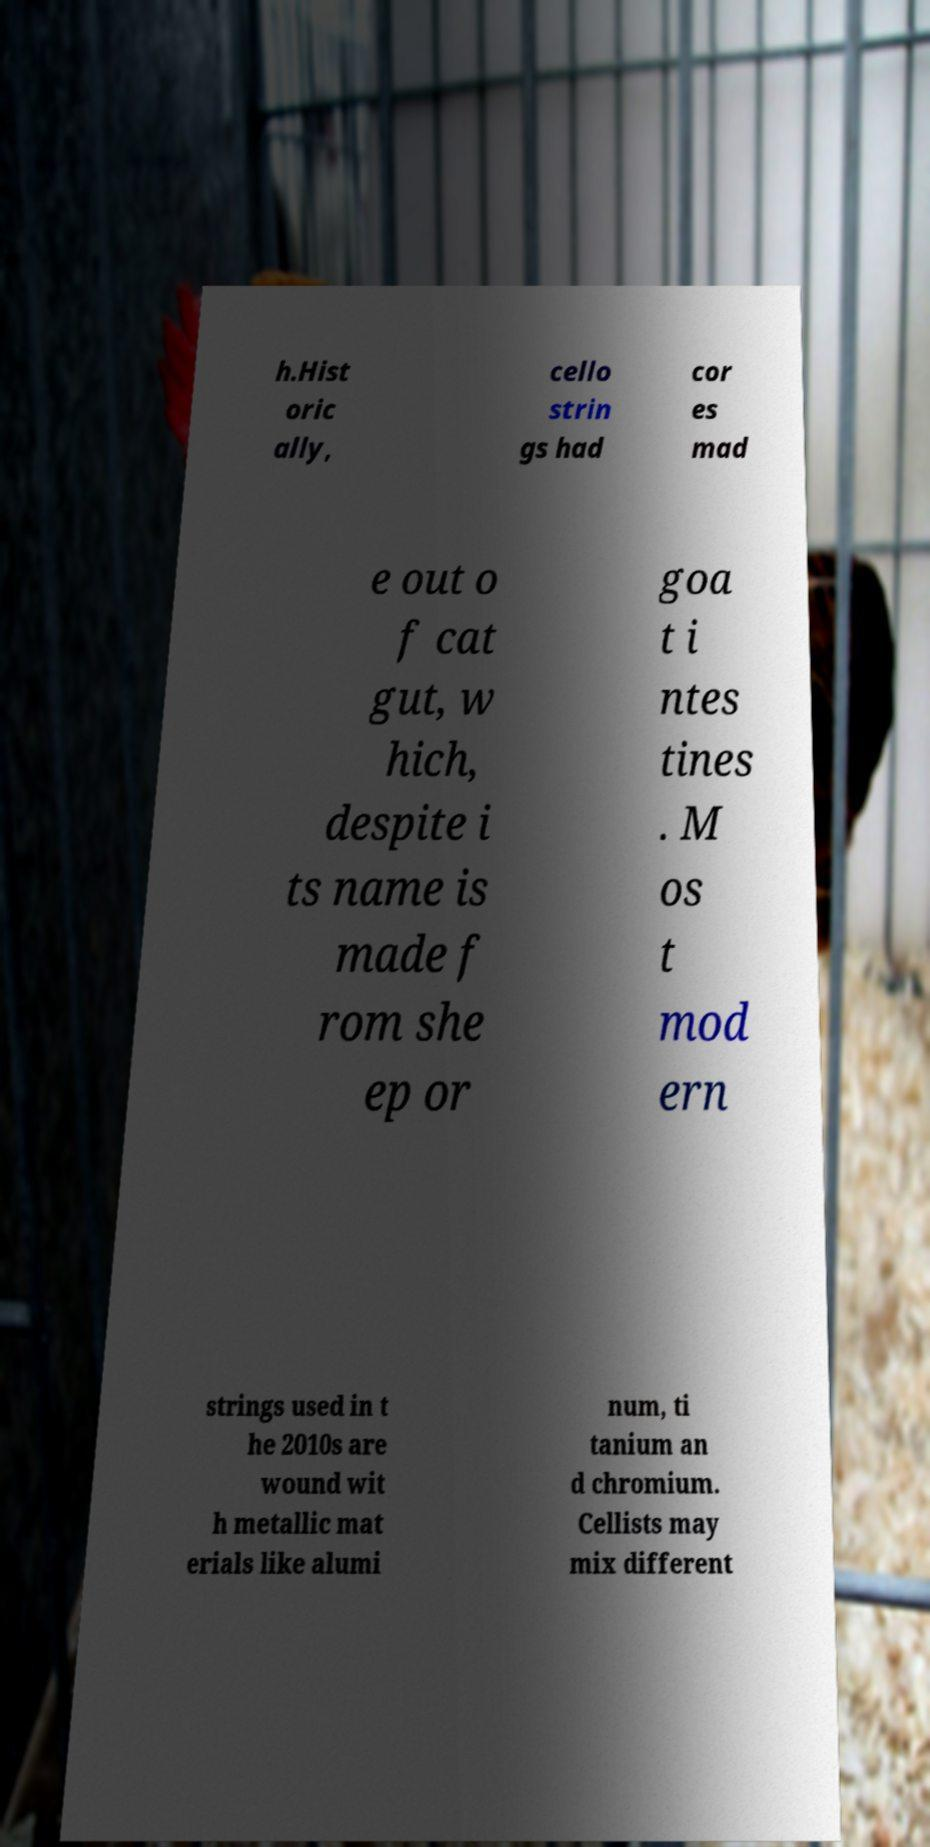For documentation purposes, I need the text within this image transcribed. Could you provide that? h.Hist oric ally, cello strin gs had cor es mad e out o f cat gut, w hich, despite i ts name is made f rom she ep or goa t i ntes tines . M os t mod ern strings used in t he 2010s are wound wit h metallic mat erials like alumi num, ti tanium an d chromium. Cellists may mix different 